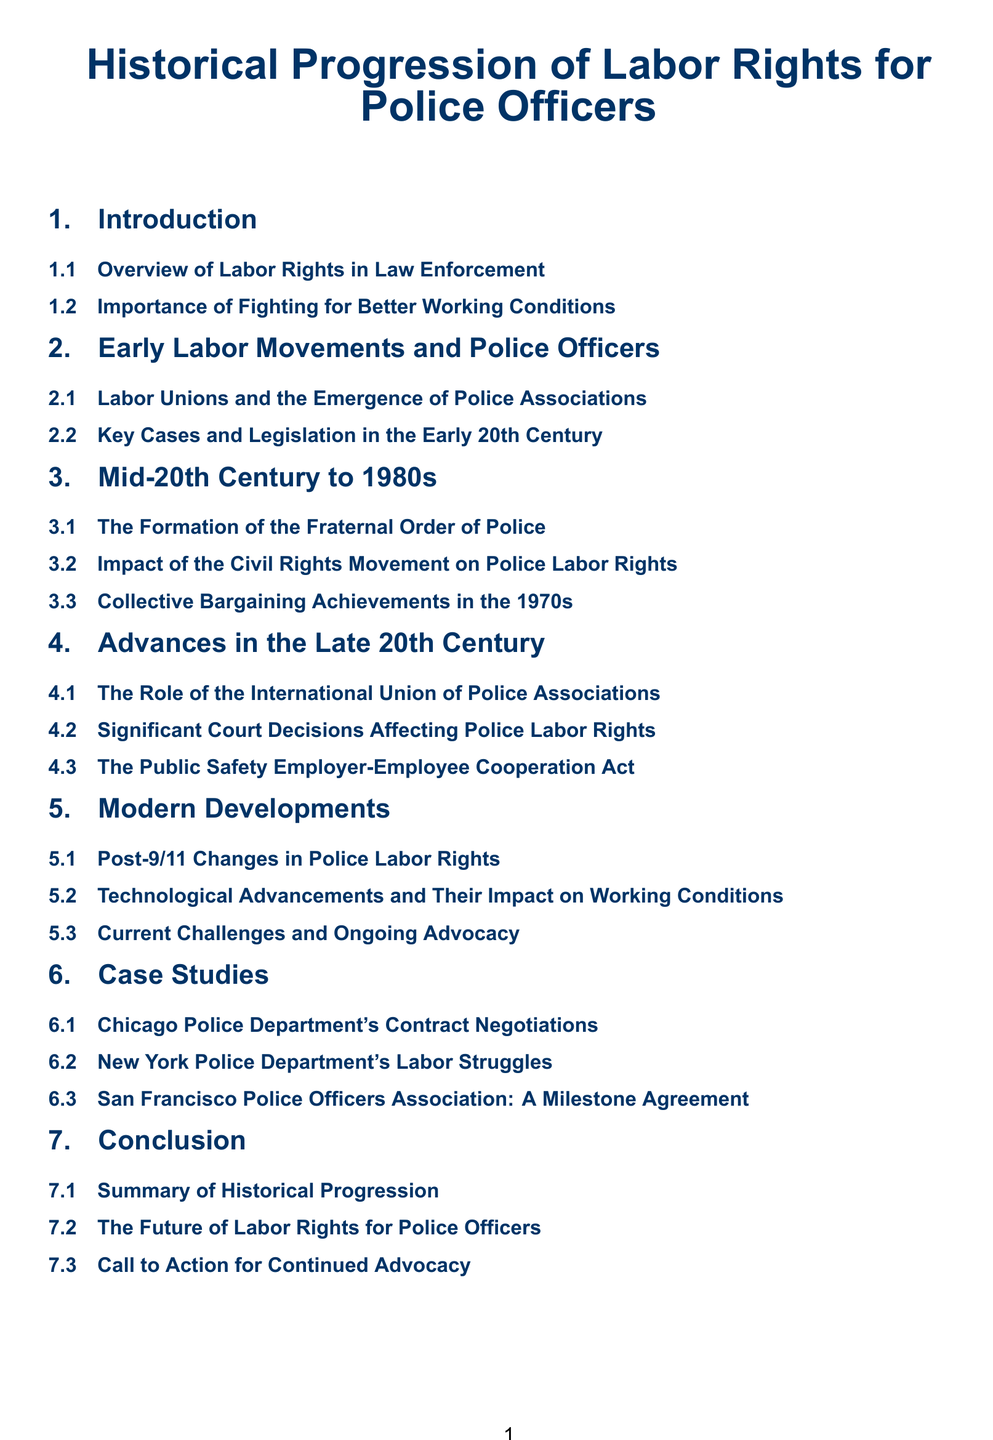What is the title of the document? The title is presented at the top of the document, highlighting the main focus on labor rights for police officers.
Answer: Historical Progression of Labor Rights for Police Officers What section discusses the importance of fighting for better working conditions? This question refers to a subsection that emphasizes why improving working conditions is crucial.
Answer: Importance of Fighting for Better Working Conditions Which organization was formed in the mid-20th century? This question refers to a specific organization discussed in the section covering that time frame.
Answer: Fraternal Order of Police What major societal movement impacted police labor rights in the 1960s and 70s? This question asks for a significant event that influenced the progression of police labor rights during that era.
Answer: Civil Rights Movement What legislation is mentioned that relates to police labor rights? This question seeks specific legislation mentioned in the document pertaining to labor rights.
Answer: Public Safety Employer-Employee Cooperation Act Which city's police department's contract negotiations is a case study? This question refers to a specific location highlighted in the document's case studies section.
Answer: Chicago Police Department's Contract Negotiations What is the focus of the 'Modern Developments' section? This question looks for the primary topic of discussion within that section of the document.
Answer: Post-9/11 Changes in Police Labor Rights What does the conclusion section call for? This question addresses the final thoughts of the document regarding future actions.
Answer: Call to Action for Continued Advocacy 